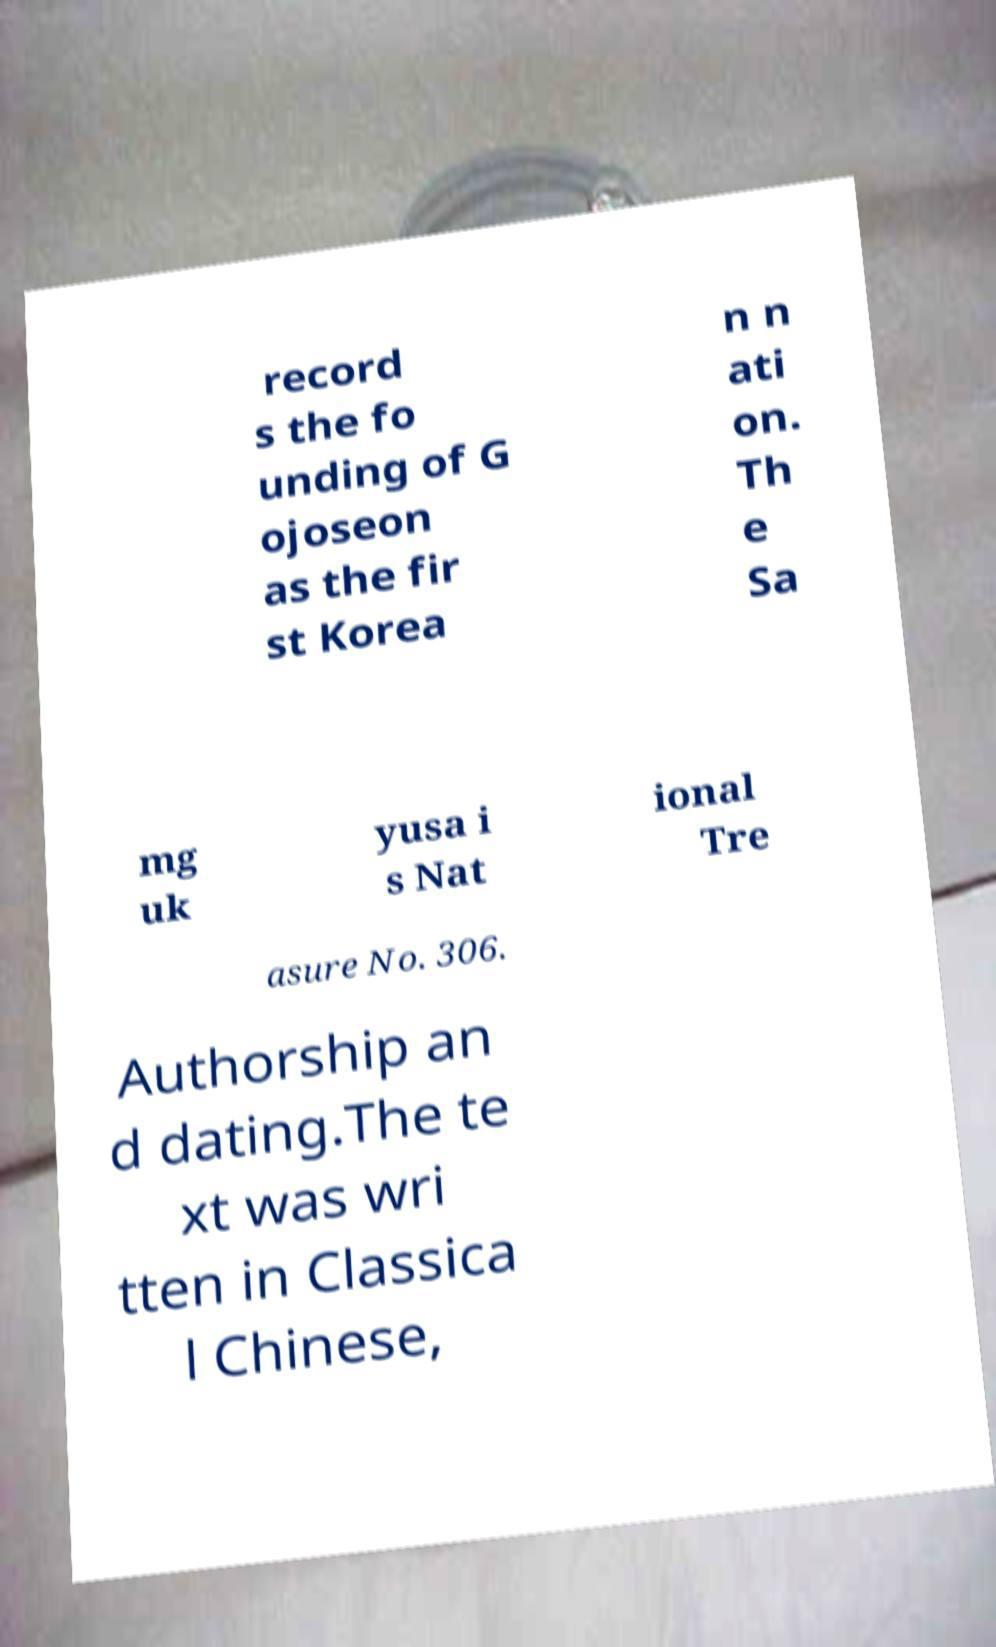There's text embedded in this image that I need extracted. Can you transcribe it verbatim? record s the fo unding of G ojoseon as the fir st Korea n n ati on. Th e Sa mg uk yusa i s Nat ional Tre asure No. 306. Authorship an d dating.The te xt was wri tten in Classica l Chinese, 